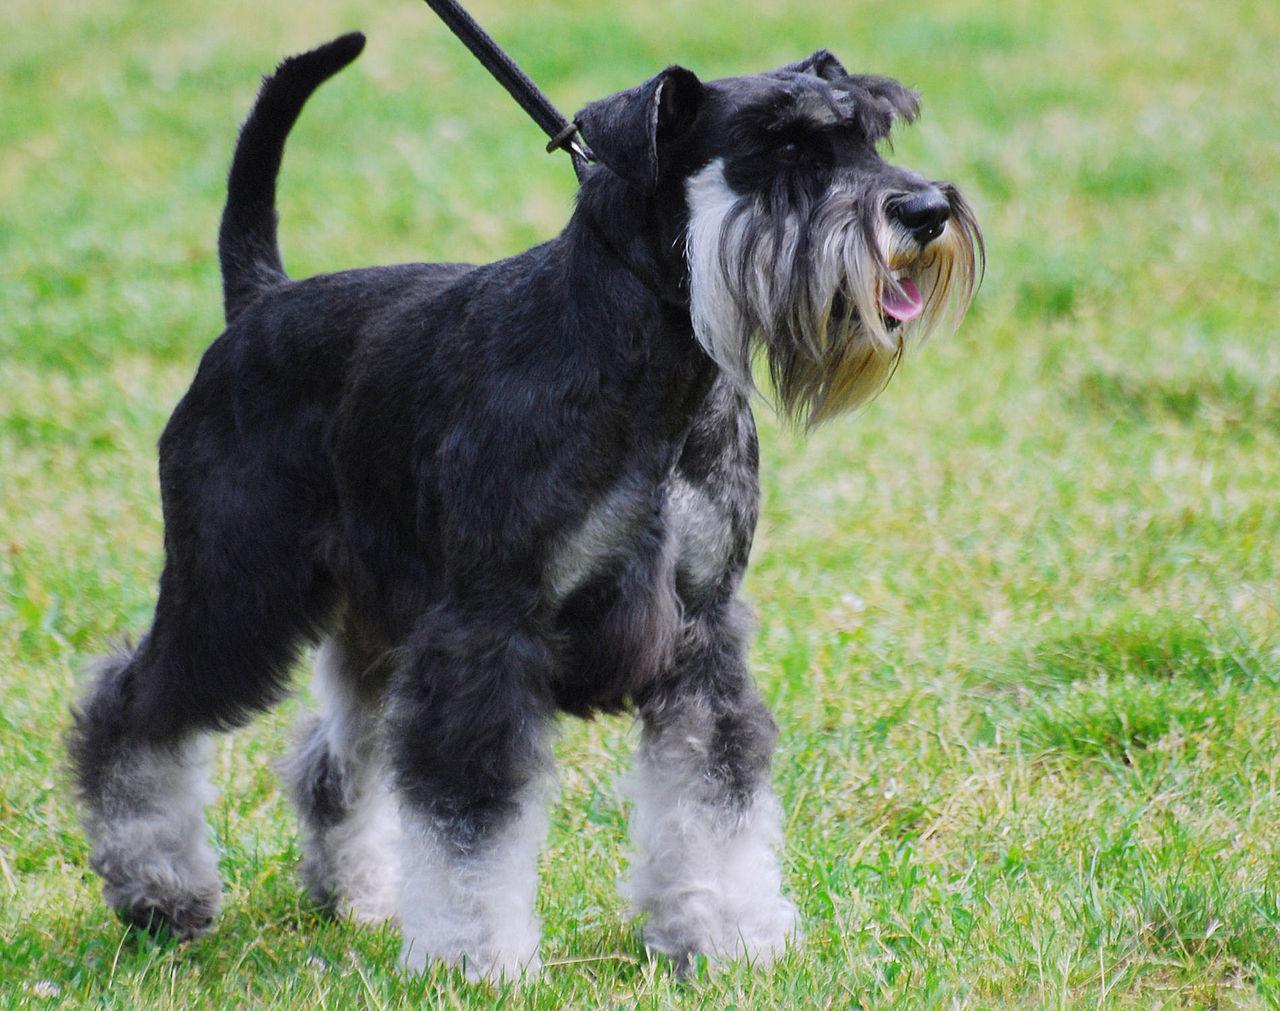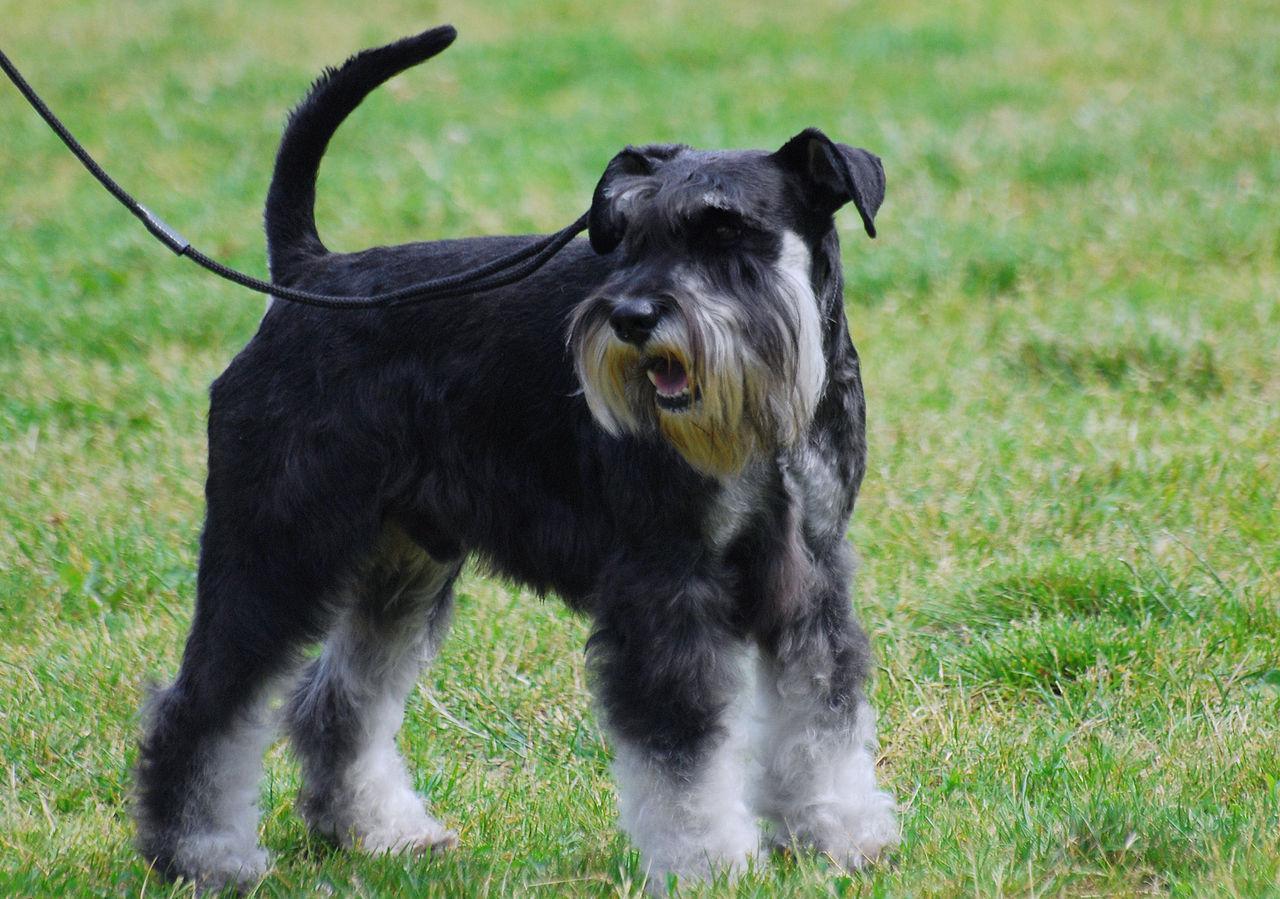The first image is the image on the left, the second image is the image on the right. For the images shown, is this caption "Both dogs are attached to a leash." true? Answer yes or no. Yes. The first image is the image on the left, the second image is the image on the right. Analyze the images presented: Is the assertion "Each image shows a leash extending from the left to a standing schnauzer dog." valid? Answer yes or no. Yes. 